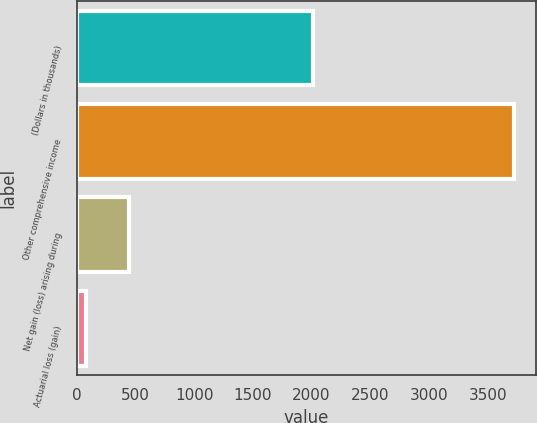<chart> <loc_0><loc_0><loc_500><loc_500><bar_chart><fcel>(Dollars in thousands)<fcel>Other comprehensive income<fcel>Net gain (loss) arising during<fcel>Actuarial loss (gain)<nl><fcel>2010<fcel>3722.1<fcel>442.1<fcel>81<nl></chart> 